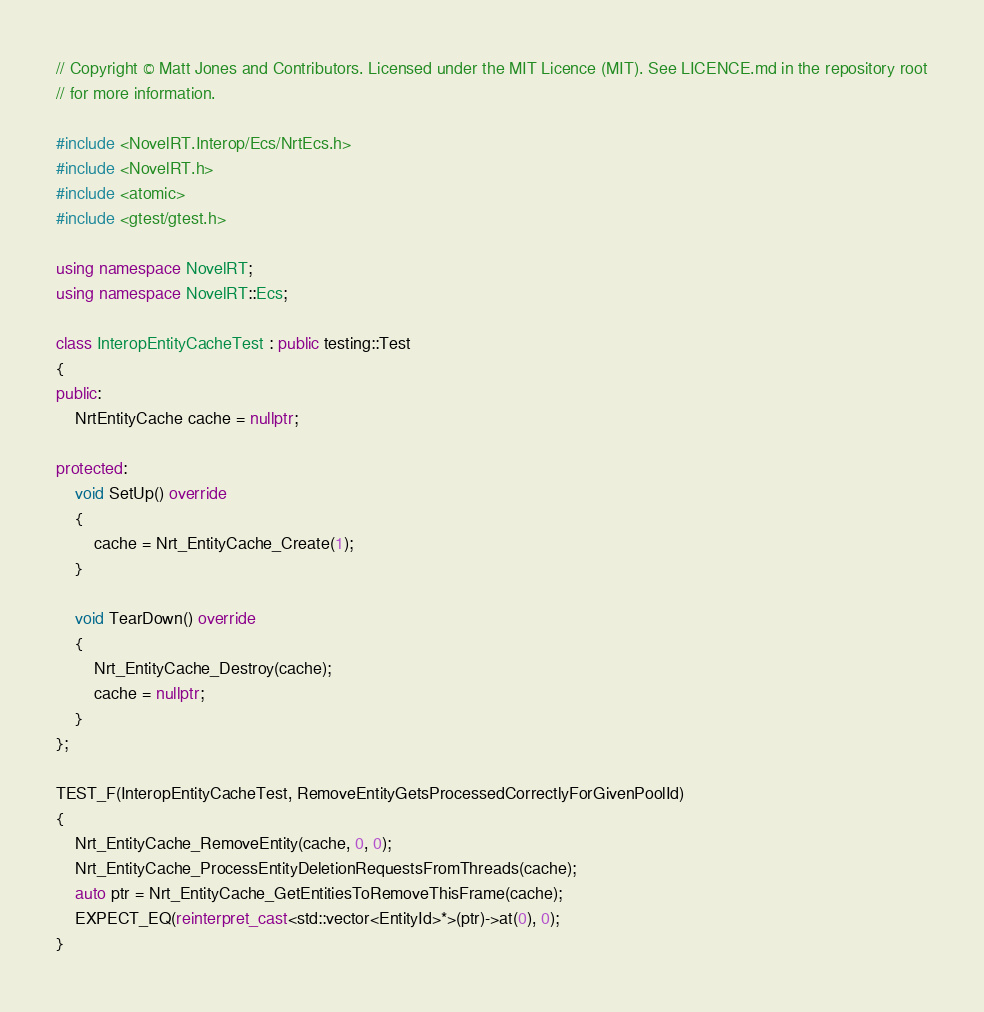Convert code to text. <code><loc_0><loc_0><loc_500><loc_500><_C++_>// Copyright © Matt Jones and Contributors. Licensed under the MIT Licence (MIT). See LICENCE.md in the repository root
// for more information.

#include <NovelRT.Interop/Ecs/NrtEcs.h>
#include <NovelRT.h>
#include <atomic>
#include <gtest/gtest.h>

using namespace NovelRT;
using namespace NovelRT::Ecs;

class InteropEntityCacheTest : public testing::Test
{
public:
    NrtEntityCache cache = nullptr;

protected:
    void SetUp() override
    {
        cache = Nrt_EntityCache_Create(1);
    }

    void TearDown() override
    {
        Nrt_EntityCache_Destroy(cache);
        cache = nullptr;
    }
};

TEST_F(InteropEntityCacheTest, RemoveEntityGetsProcessedCorrectlyForGivenPoolId)
{
    Nrt_EntityCache_RemoveEntity(cache, 0, 0);
    Nrt_EntityCache_ProcessEntityDeletionRequestsFromThreads(cache);
    auto ptr = Nrt_EntityCache_GetEntitiesToRemoveThisFrame(cache);
    EXPECT_EQ(reinterpret_cast<std::vector<EntityId>*>(ptr)->at(0), 0);
}
</code> 